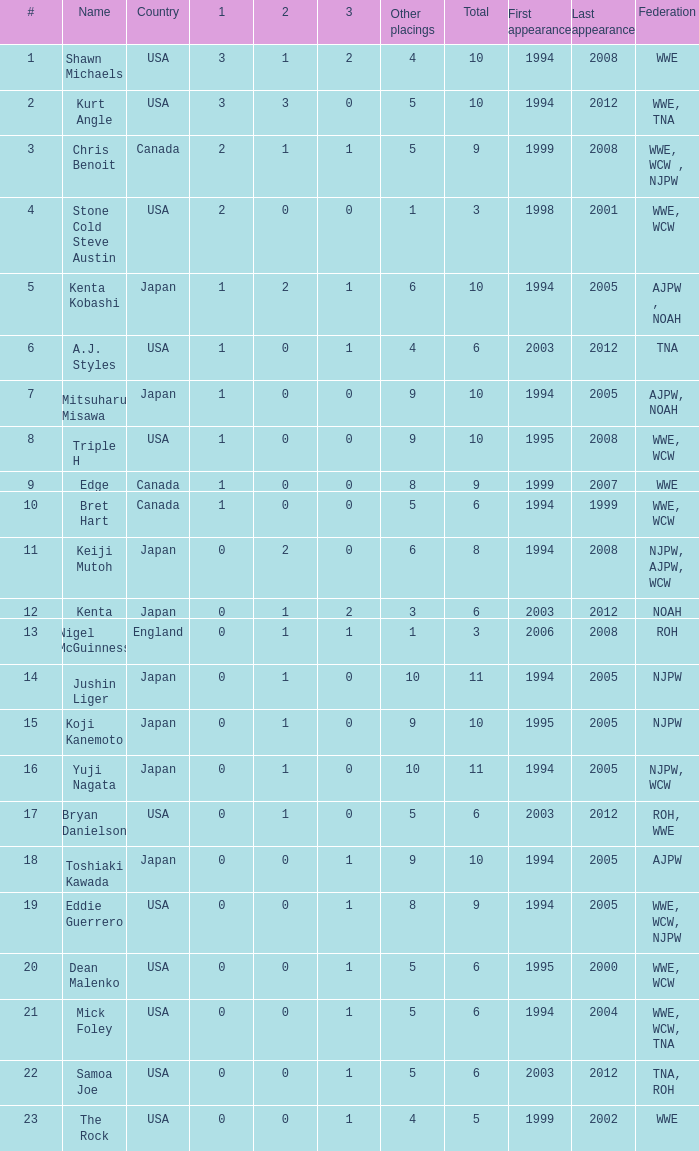How many times has a wrestler from the country of England wrestled in this event? 1.0. 